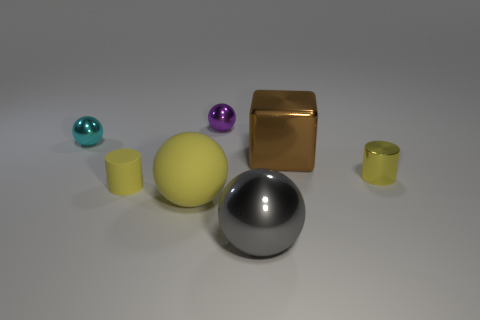Subtract 1 spheres. How many spheres are left? 3 Add 2 big brown metallic things. How many objects exist? 9 Subtract all balls. How many objects are left? 3 Subtract 0 blue cylinders. How many objects are left? 7 Subtract all red cylinders. Subtract all blocks. How many objects are left? 6 Add 5 large brown metallic things. How many large brown metallic things are left? 6 Add 4 shiny cylinders. How many shiny cylinders exist? 5 